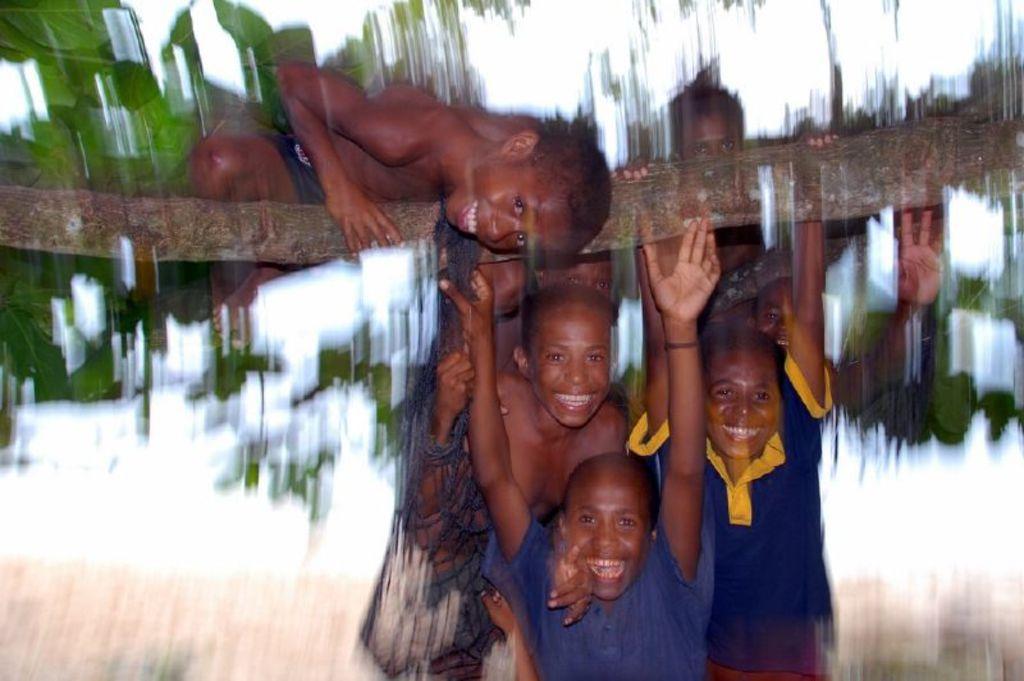Describe this image in one or two sentences. In this image I can see group of people and I can see few people are holding the trunk and I can see the blurred background. 